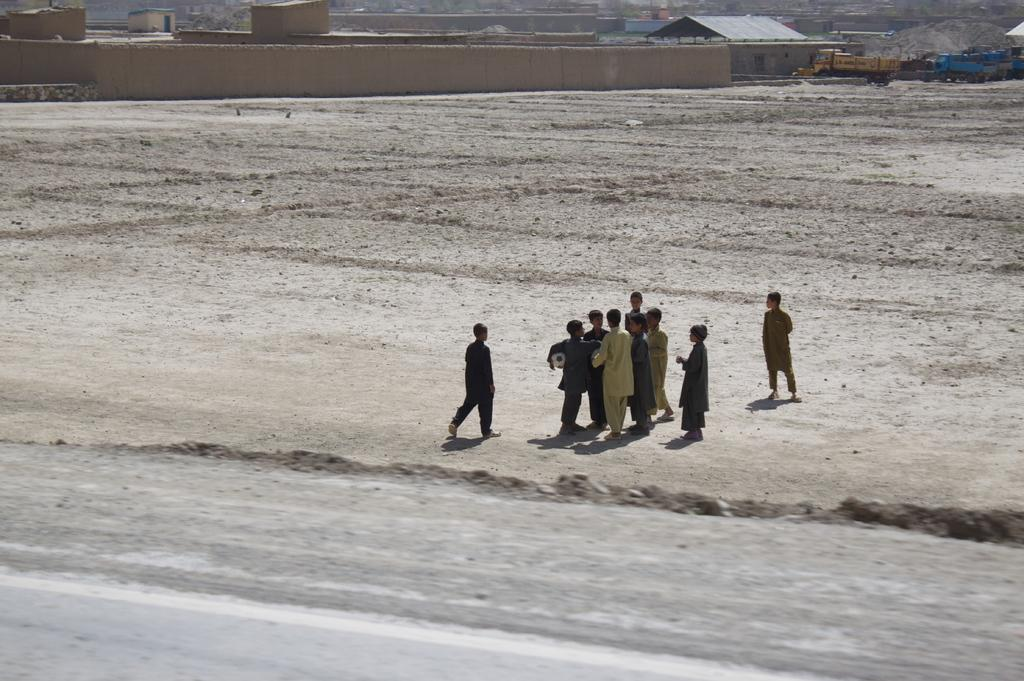What is happening in the middle of the image? There are people standing in the middle of the image. What can be seen at the top of the image? Vehicles and buildings are visible at the top of the image. What is the purpose of the wall in the image? The wall's purpose is not specified in the image, but it could be a boundary or a part of a structure. How does the wall express anger in the image? The wall does not express anger in the image, as it is an inanimate object and cannot display emotions. 